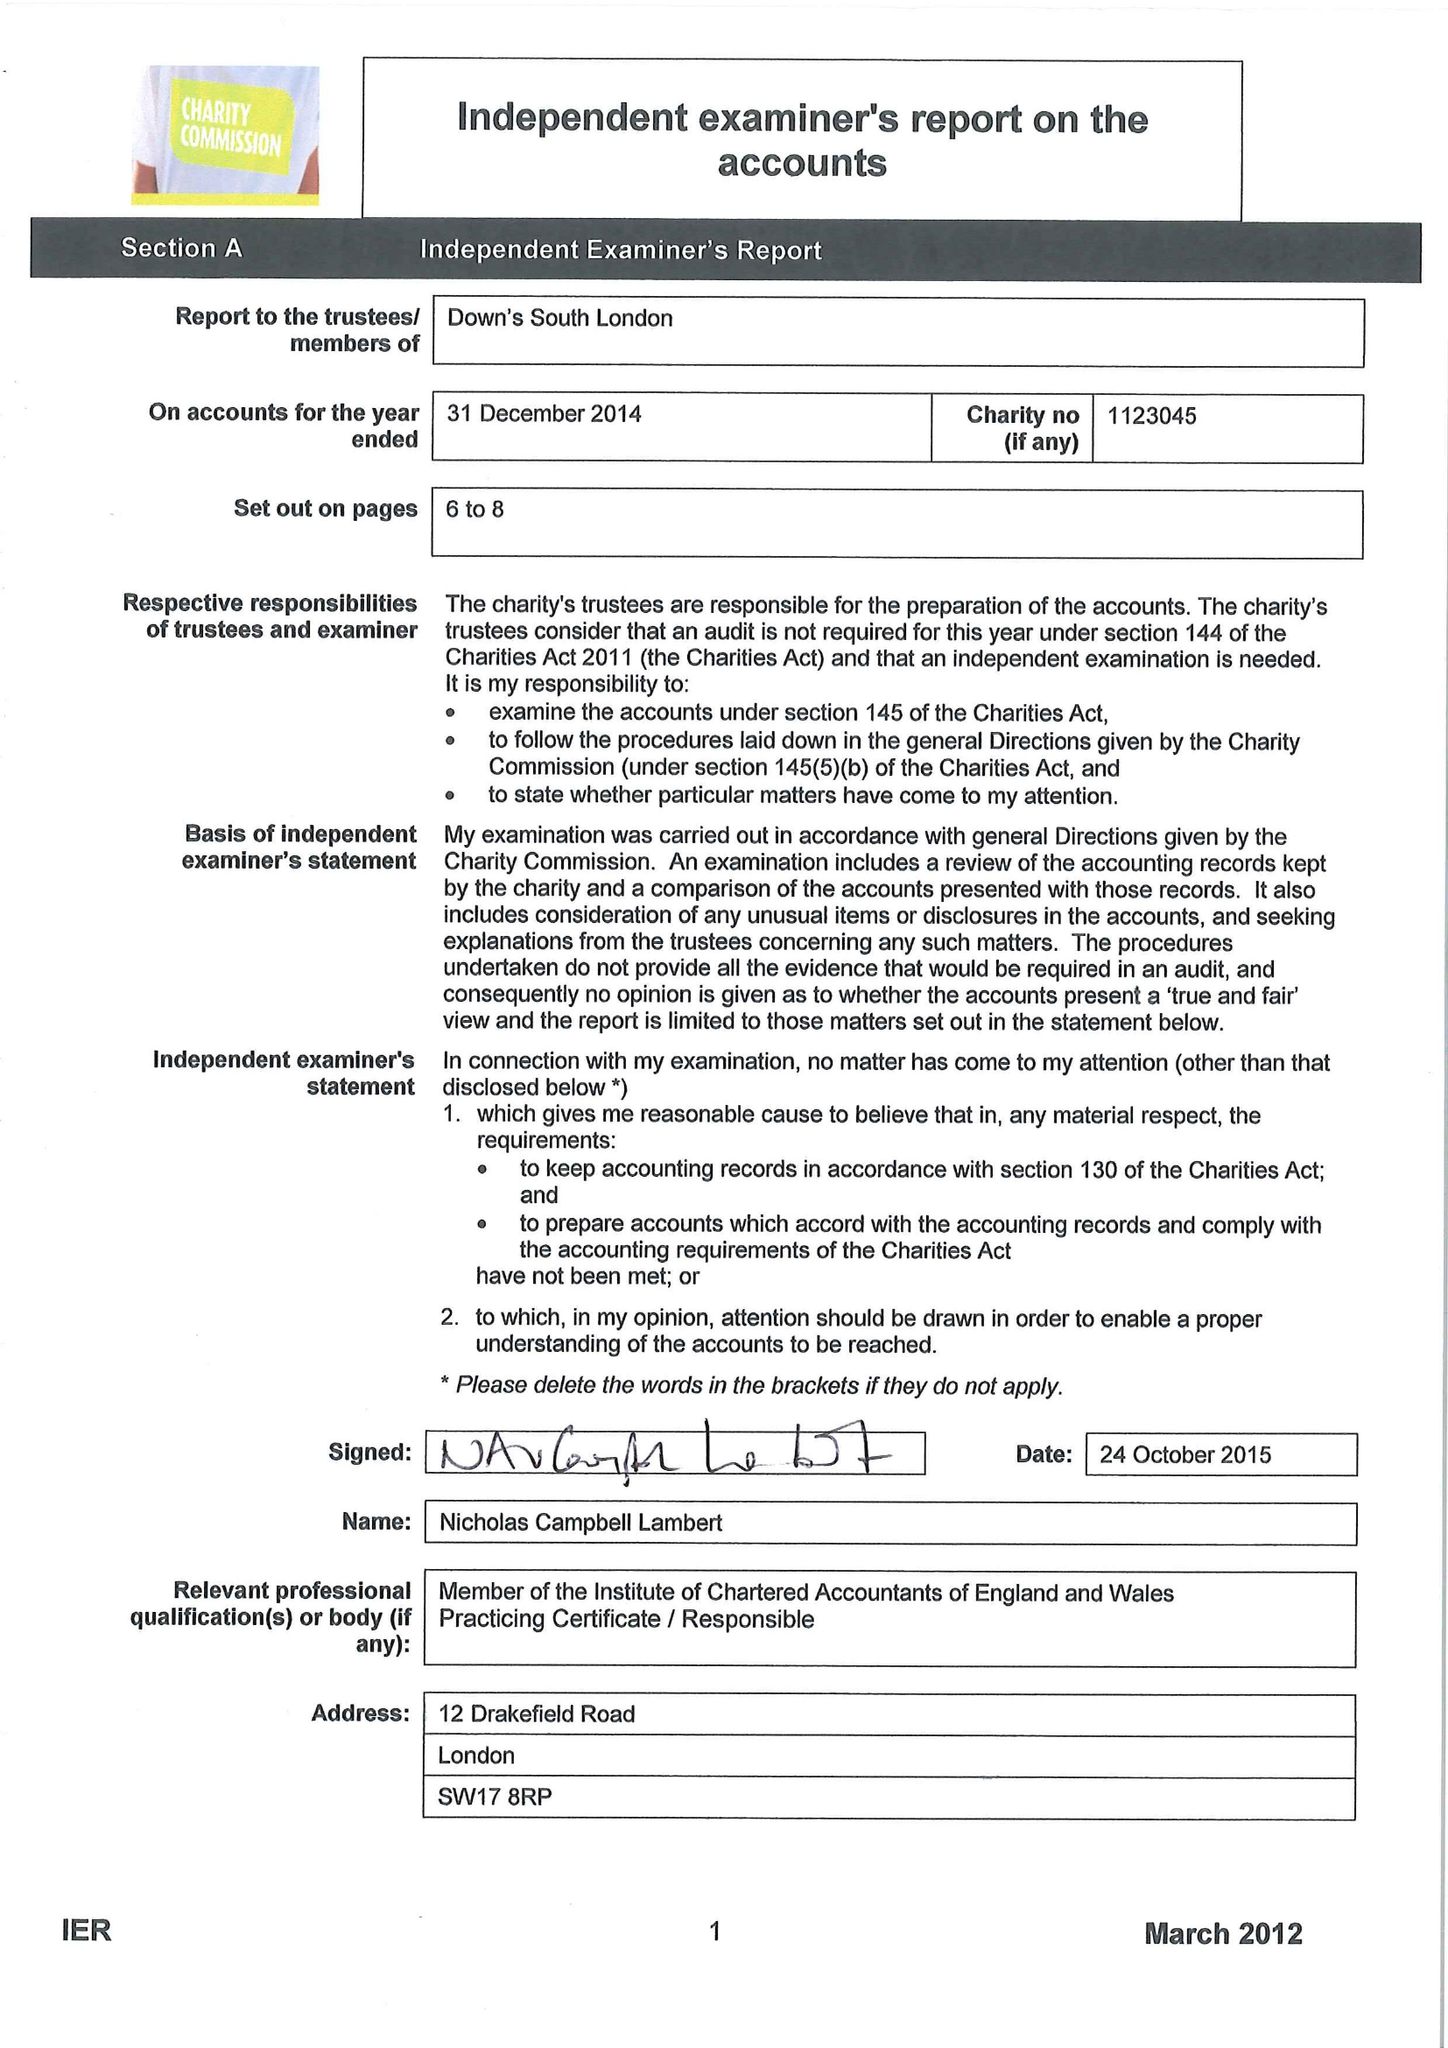What is the value for the charity_name?
Answer the question using a single word or phrase. Down's South London 